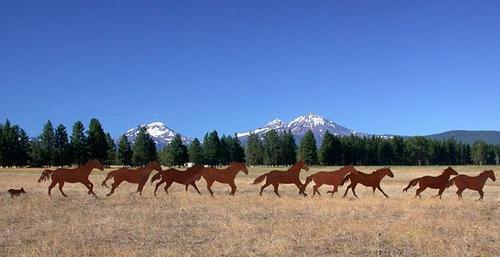How many horses are there?
Give a very brief answer. 9. How many mountain peaks are visible?
Give a very brief answer. 3. 